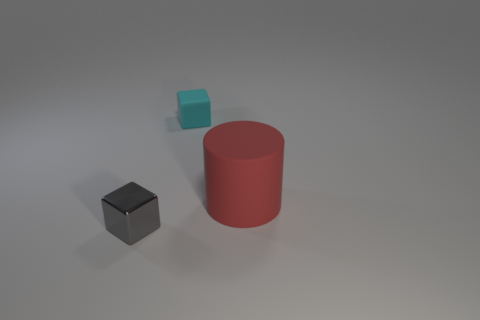Add 2 large cyan metallic balls. How many objects exist? 5 Subtract all cyan blocks. How many blocks are left? 1 Subtract 2 blocks. How many blocks are left? 0 Subtract all cubes. How many objects are left? 1 Subtract all red cylinders. How many purple cubes are left? 0 Subtract all tiny gray things. Subtract all cyan matte cubes. How many objects are left? 1 Add 1 small blocks. How many small blocks are left? 3 Add 3 small cylinders. How many small cylinders exist? 3 Subtract 0 yellow cylinders. How many objects are left? 3 Subtract all cyan cylinders. Subtract all brown cubes. How many cylinders are left? 1 